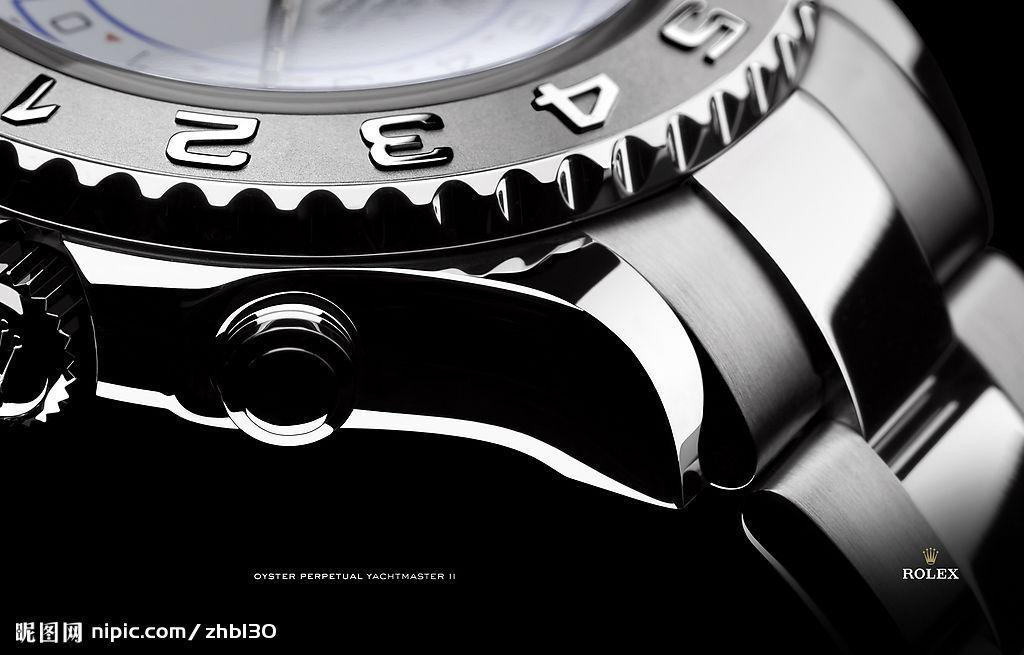<image>
Present a compact description of the photo's key features. An advertisement for Rolex watches shows the numbers 1 through 5. 